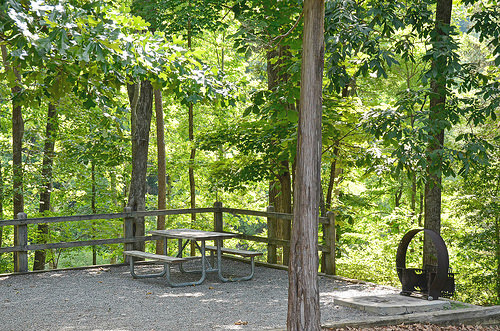<image>
Can you confirm if the tree is above the bench? Yes. The tree is positioned above the bench in the vertical space, higher up in the scene. 